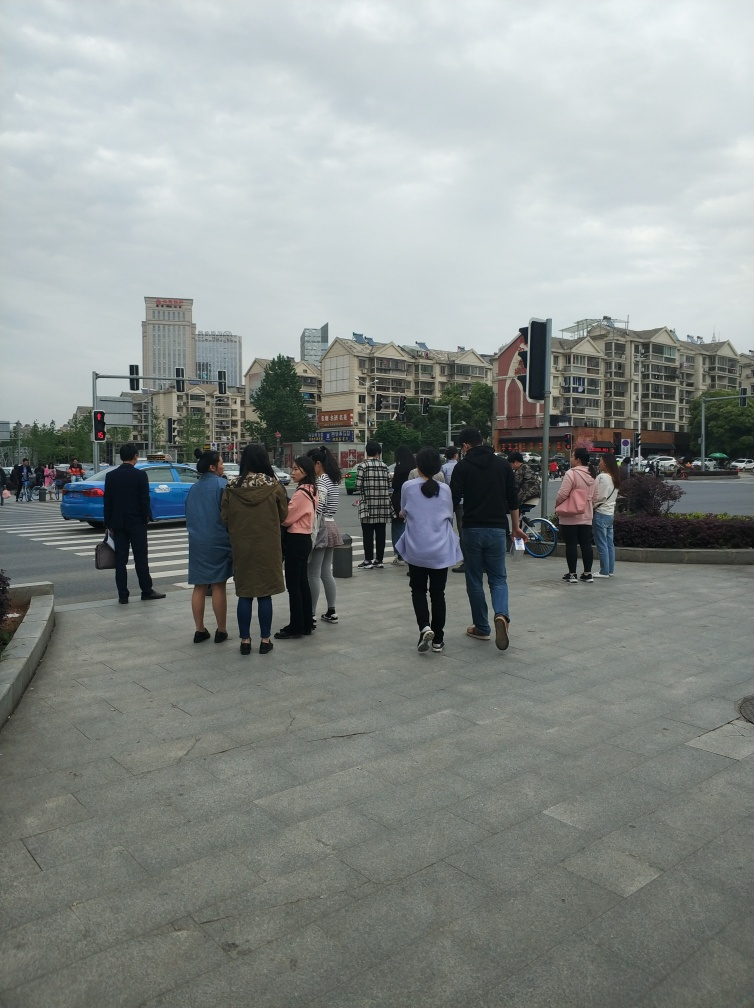Are there any visible distractions in this photo?
 No 